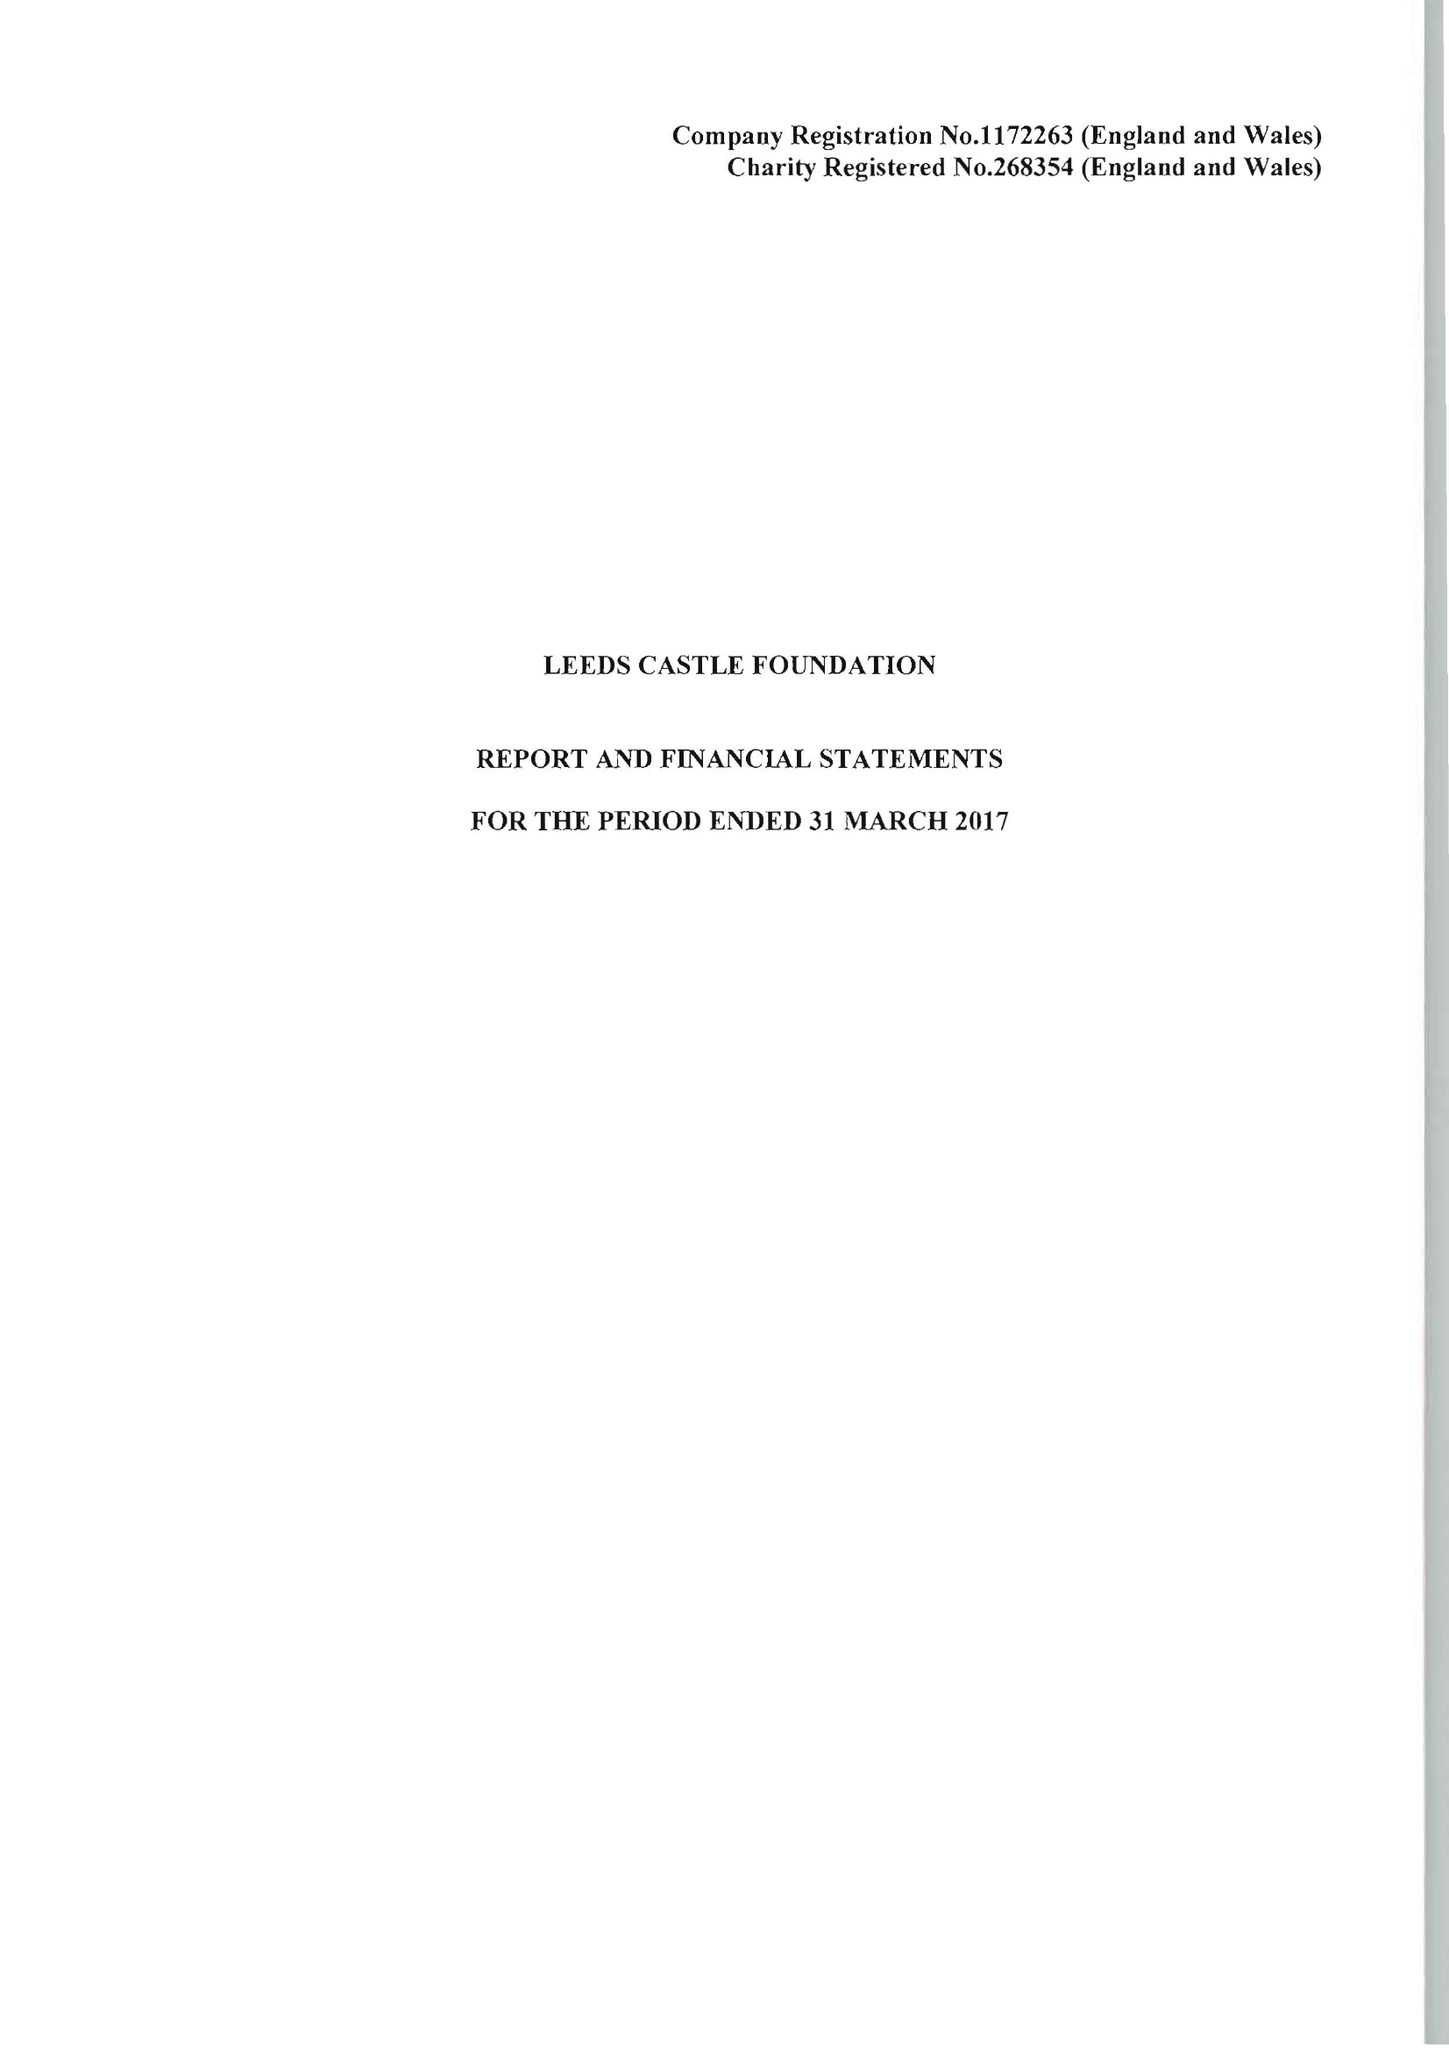What is the value for the address__street_line?
Answer the question using a single word or phrase. BROOMFIELD 